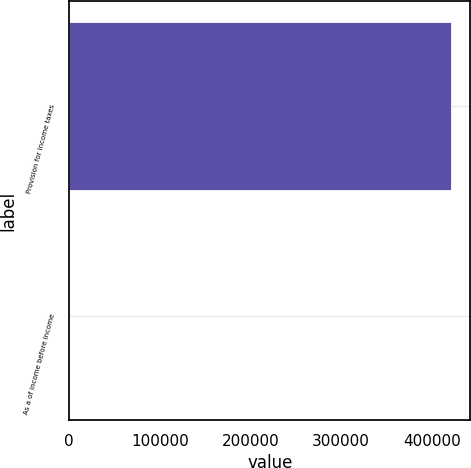<chart> <loc_0><loc_0><loc_500><loc_500><bar_chart><fcel>Provision for income taxes<fcel>As a of income before income<nl><fcel>421418<fcel>27<nl></chart> 